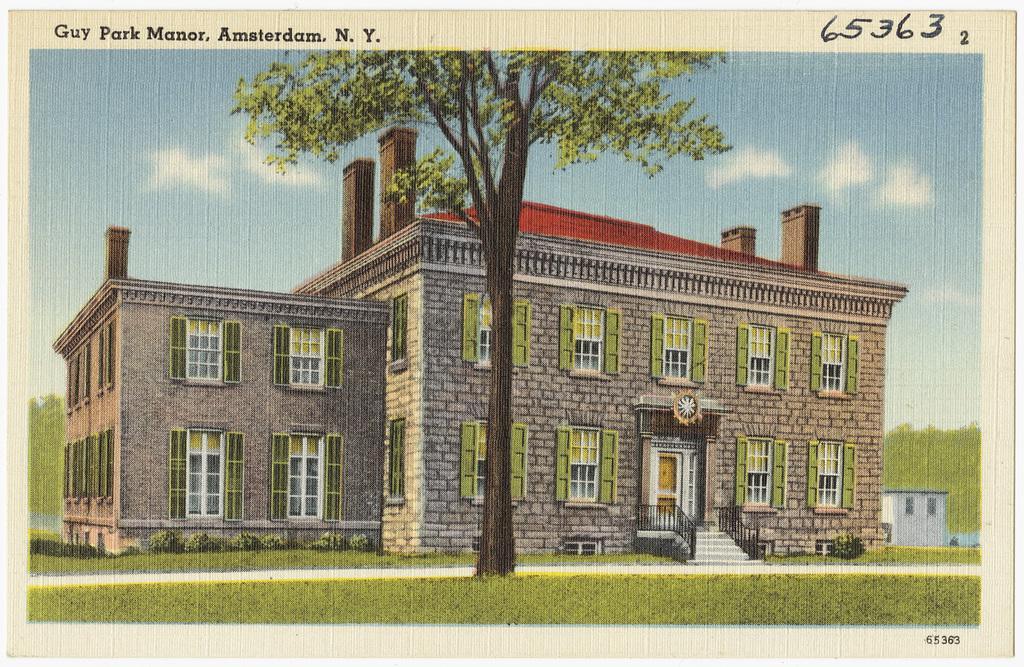In one or two sentences, can you explain what this image depicts? This is a picture and here we can see buildings and there is a tree. At the bottom, there is ground and at the top, there are clouds in the sky. 